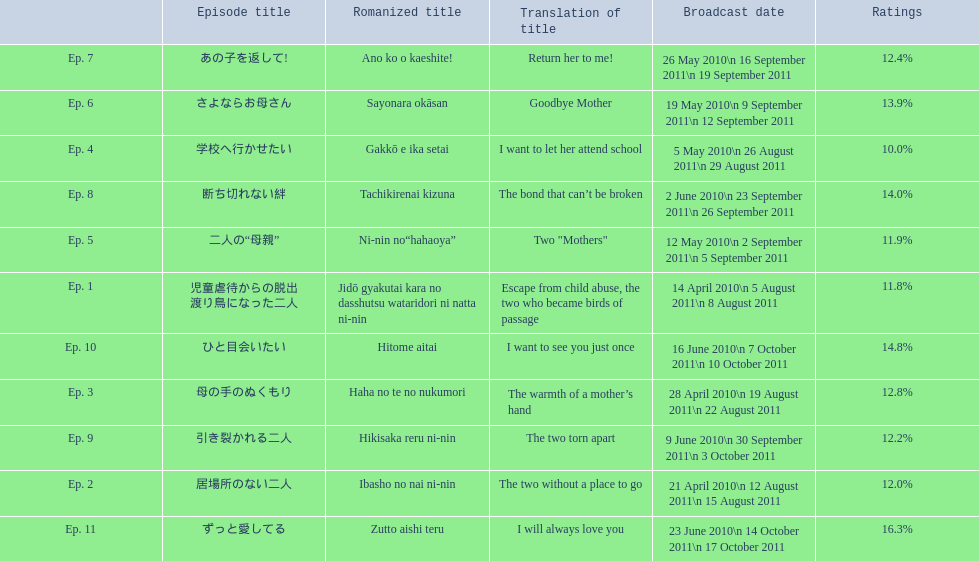What are all the titles the episodes of the mother tv series? 児童虐待からの脱出 渡り鳥になった二人, 居場所のない二人, 母の手のぬくもり, 学校へ行かせたい, 二人の“母親”, さよならお母さん, あの子を返して!, 断ち切れない絆, 引き裂かれる二人, ひと目会いたい, ずっと愛してる. What are all of the ratings for each of the shows? 11.8%, 12.0%, 12.8%, 10.0%, 11.9%, 13.9%, 12.4%, 14.0%, 12.2%, 14.8%, 16.3%. What is the highest score for ratings? 16.3%. What episode corresponds to that rating? ずっと愛してる. 